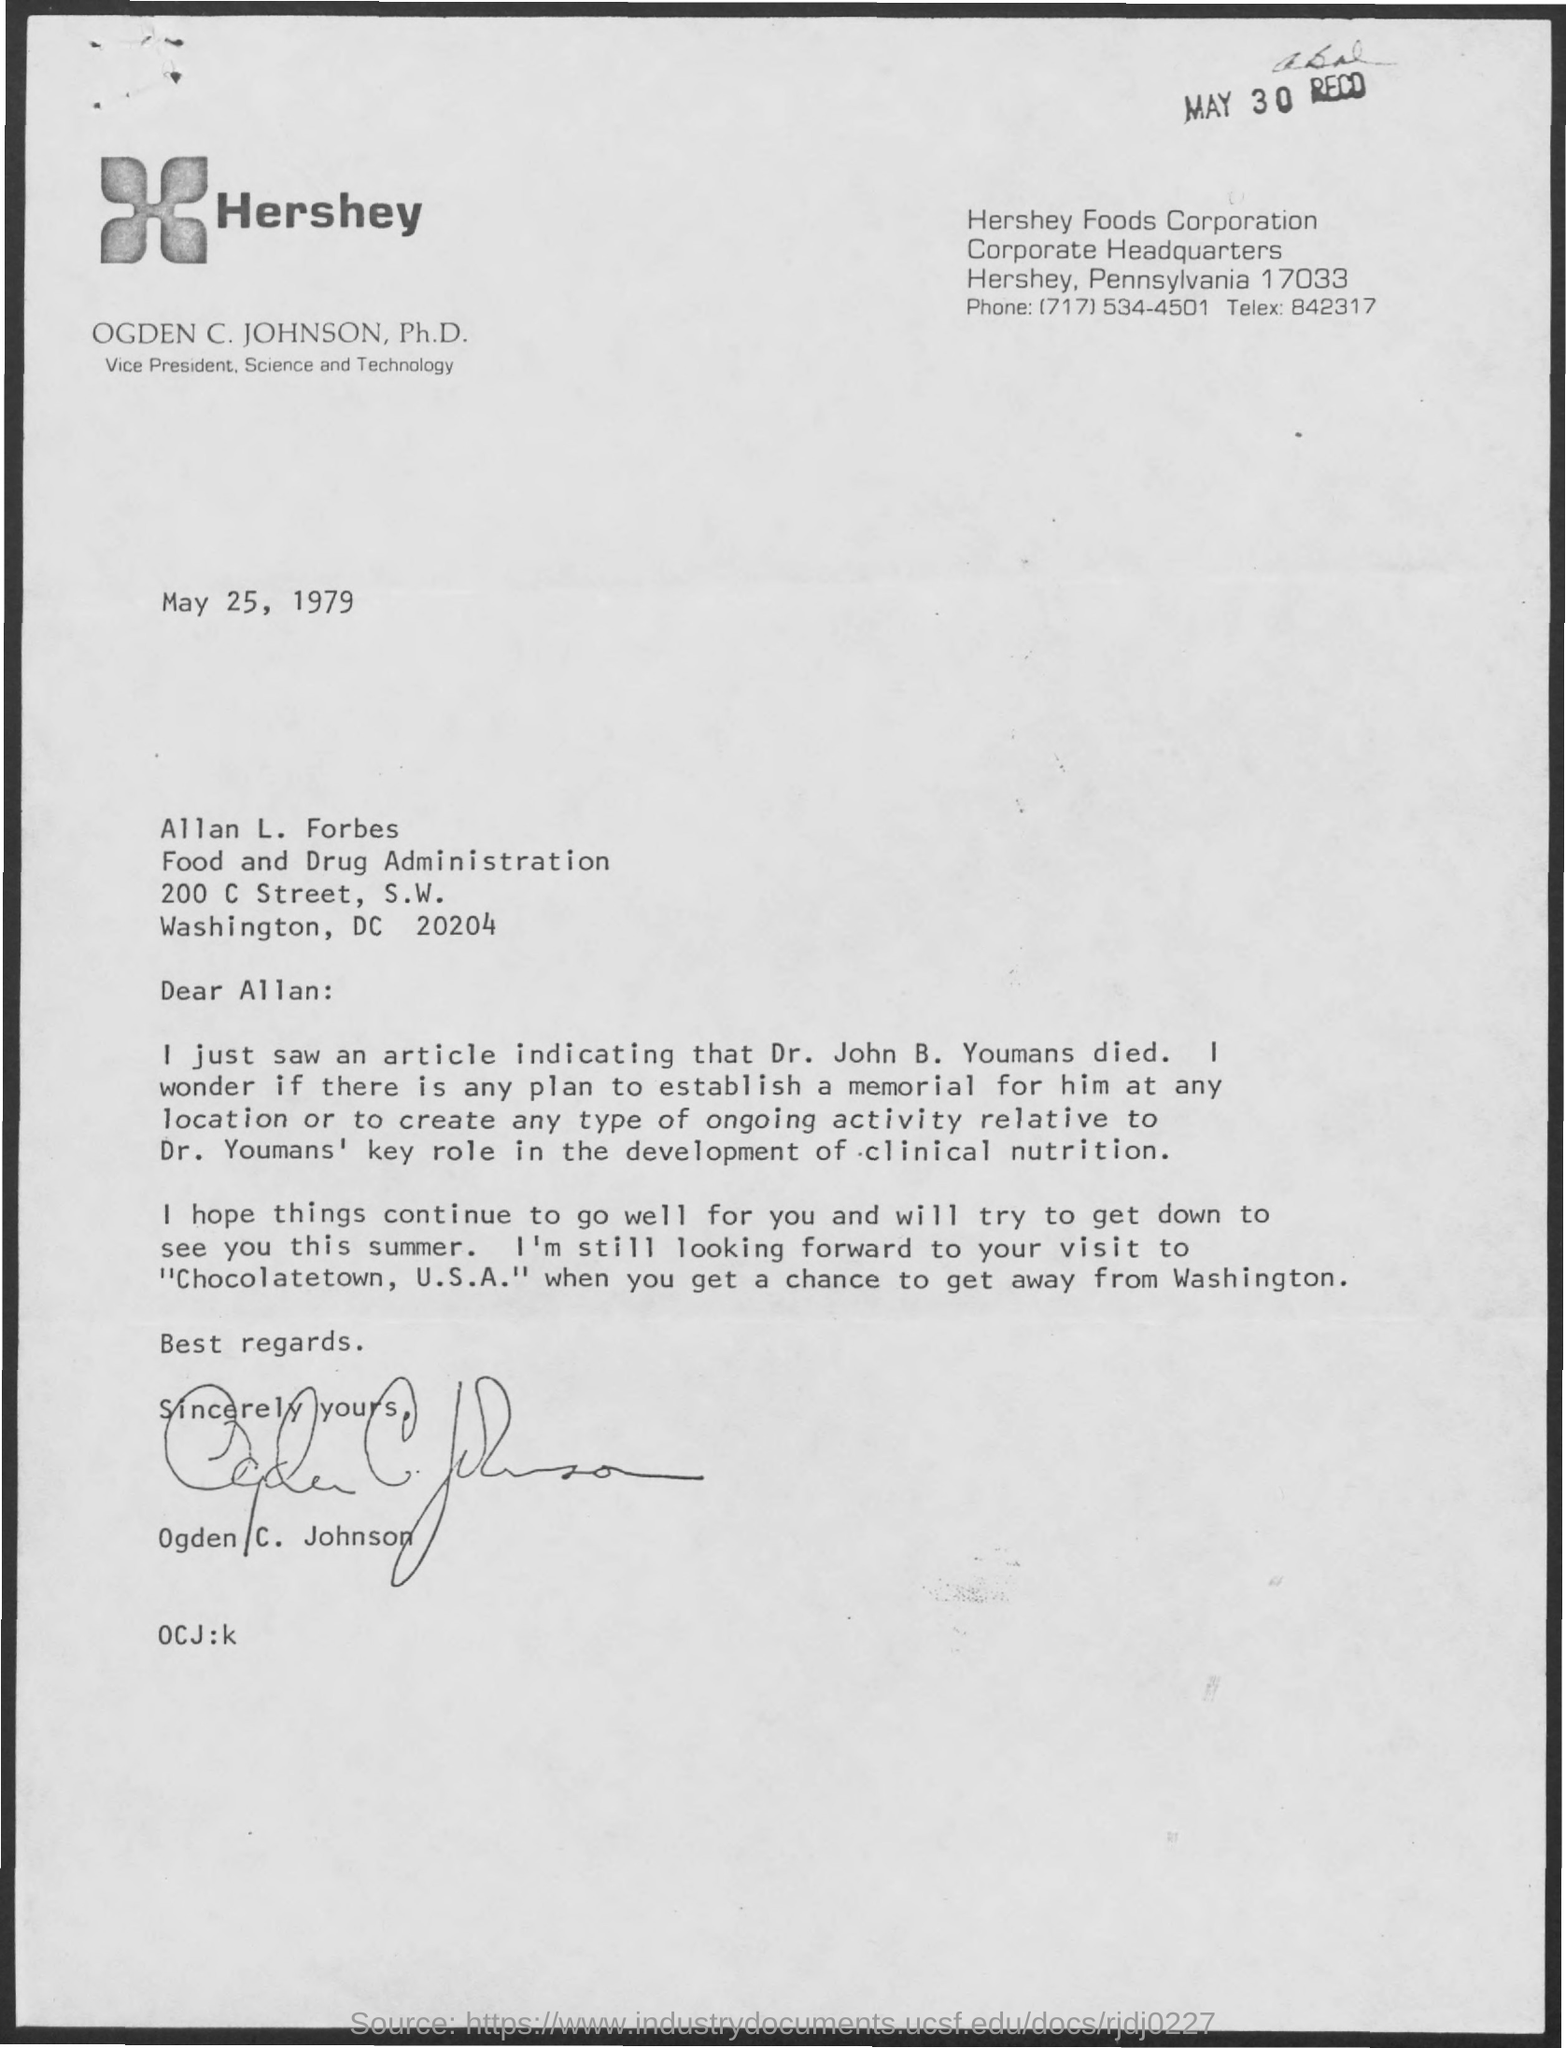What is the Telex Number ?
Your response must be concise. 842317. When is the Memorandum dated on ?
Offer a very short reply. May 25, 1979. What is the Phone Number ?
Keep it short and to the point. (717) 534-4501. 